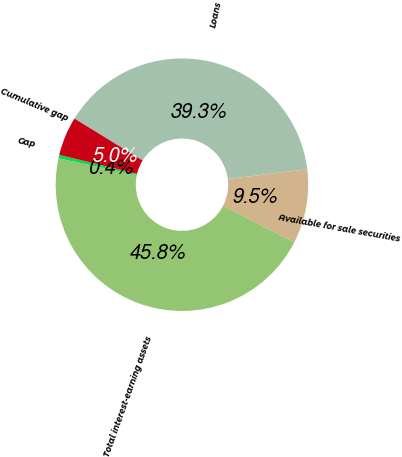Convert chart to OTSL. <chart><loc_0><loc_0><loc_500><loc_500><pie_chart><fcel>Loans<fcel>Available for sale securities<fcel>Total interest-earning assets<fcel>Gap<fcel>Cumulative gap<nl><fcel>39.27%<fcel>9.52%<fcel>45.78%<fcel>0.45%<fcel>4.98%<nl></chart> 